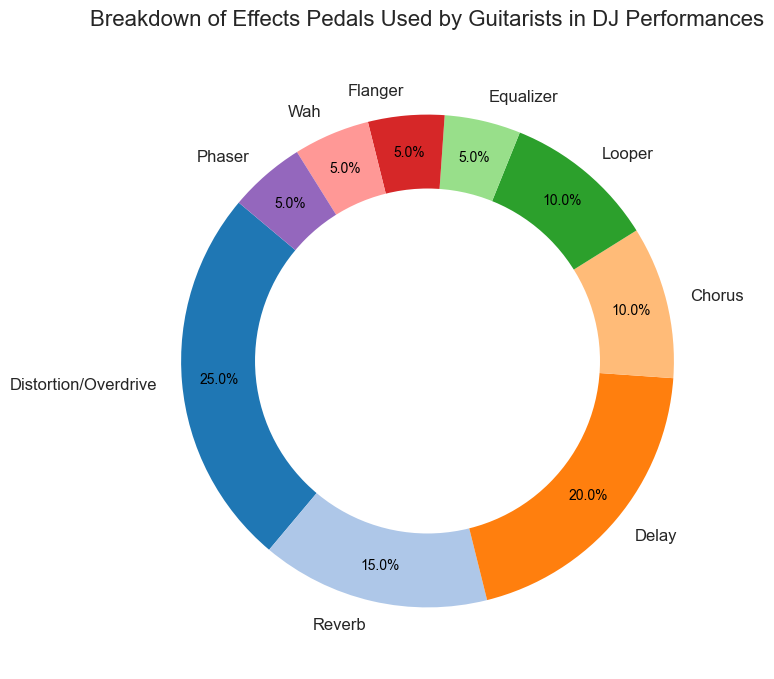What is the most used effects pedal in DJ performances? The visual representation shows that "Distortion/Overdrive" has the largest section of the ring chart, indicating the highest usage percentage.
Answer: Distortion/Overdrive Which two effects pedals have the same usage percentage? By visual inspection, it's clear that "Looper," "Flanger," "Wah," and "Phaser" all have sections of the same size, indicating equal usage percentages.
Answer: Looper, Flanger, Wah, Phaser What is the combined usage percentage of Delay and Reverb effects? From the chart, Delay has a 20% usage, and Reverb has a 15% usage. Adding these together gives: 20% + 15% = 35%
Answer: 35% Is the usage percentage of Chorus higher than Equalizer? By comparing the sections, it's visible that the section for Chorus is larger than that for Equalizer, indicating a higher usage percentage for Chorus.
Answer: Yes How much more is the usage percentage of Distortion/Overdrive compared to Chorus? Distortion/Overdrive has a usage percentage of 25%, and Chorus has 10%. Subtracting the two: 25% - 10% = 15%
Answer: 15% What is the total usage percentage of all effects pedals that have a 5% usage each? Summing up the usage of all pedals that have 5%: Equalizer (5%) + Flanger (5%) + Wah (5%) + Phaser (5%) gives: 5% * 4 = 20%
Answer: 20% Among the pedals listed, which one has the lowest representation along with Equalizer? By looking at the smallest sections, Equalizer, Flanger, Wah, and Phaser all share the smallest and equal sections.
Answer: Flanger, Wah, Phaser How does the usage percentage of Reverb compare to the combined percentage of Flanger and Wah? Reverb has a 15% usage, and both Flanger and Wah have 5% each. Combined usage of Flanger and Wah is: 5% + 5% = 10%. 15% (Reverb) is greater than 10% (Flanger + Wah).
Answer: Greater than What percentage of the total usage do Delay and Looper together account for? Delay has a usage of 20% and Looper has 10%. Adding these gives: 20% + 10% = 30%
Answer: 30% What is the difference in usage between the most used and least used effects pedals? The most used is Distortion/Overdrive at 25% and the least used are Equalizer, Flanger, Wah, and Phaser, each at 5%. The difference is: 25% - 5% = 20%
Answer: 20% 